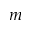Convert formula to latex. <formula><loc_0><loc_0><loc_500><loc_500>\text  mu m</formula> 